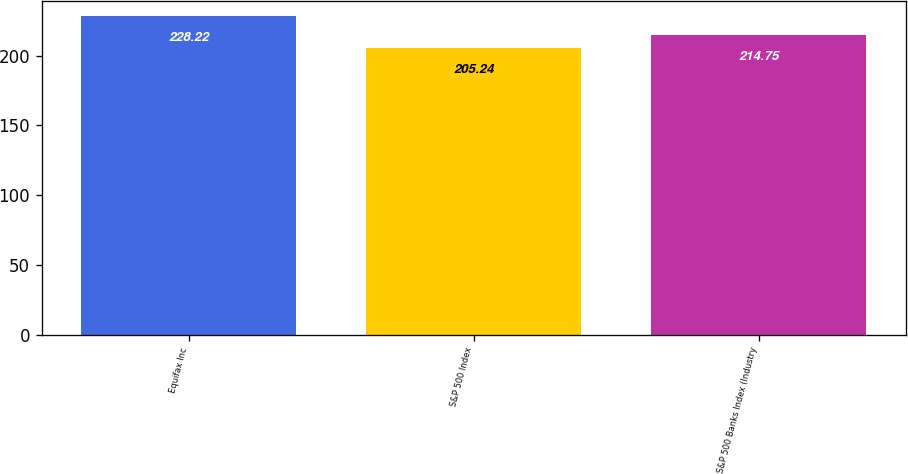Convert chart to OTSL. <chart><loc_0><loc_0><loc_500><loc_500><bar_chart><fcel>Equifax Inc<fcel>S&P 500 Index<fcel>S&P 500 Banks Index (Industry<nl><fcel>228.22<fcel>205.24<fcel>214.75<nl></chart> 